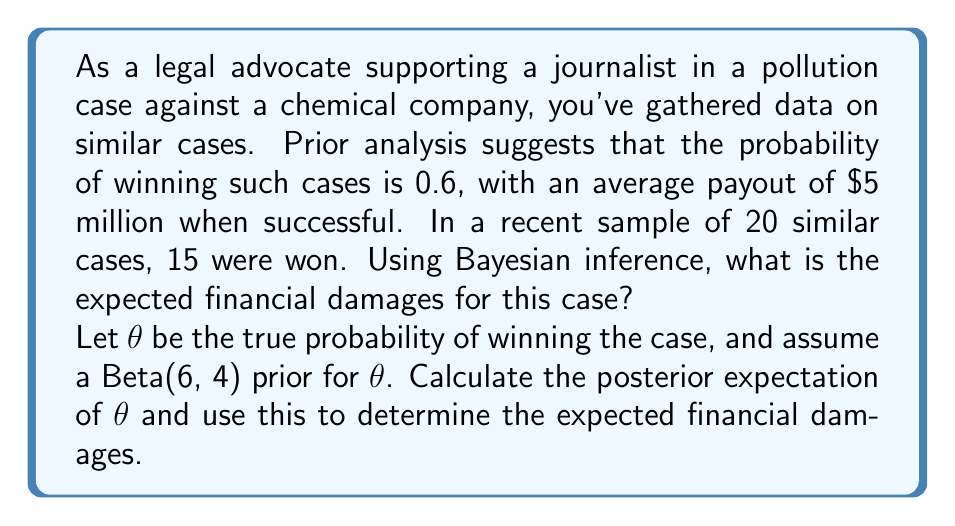Give your solution to this math problem. To solve this problem, we'll use Bayesian inference with a Beta-Binomial model:

1) Prior distribution: Beta(6, 4)
   This reflects our initial belief that the probability of winning is around 0.6 (6 / (6 + 4) = 0.6)

2) Likelihood: Binomial(20, 15)
   We observed 15 successes out of 20 trials

3) Posterior distribution: Beta(α + x, β + n - x)
   Where α = 6, β = 4 (prior parameters)
         x = 15 (successes), n = 20 (trials)
   
   Posterior: Beta(6 + 15, 4 + 20 - 15) = Beta(21, 9)

4) Posterior expectation of $\theta$:
   $$E[\theta|x] = \frac{\alpha + x}{\alpha + \beta + n} = \frac{21}{21 + 9} = \frac{21}{30} = 0.7$$

5) Expected financial damages:
   We multiply the posterior probability of winning by the average payout:
   
   $$\text{Expected Damages} = E[\theta|x] \times \text{Average Payout}$$
   $$= 0.7 \times \$5,000,000 = \$3,500,000$$
Answer: The expected financial damages for this case, using Bayesian inference, are $3,500,000. 